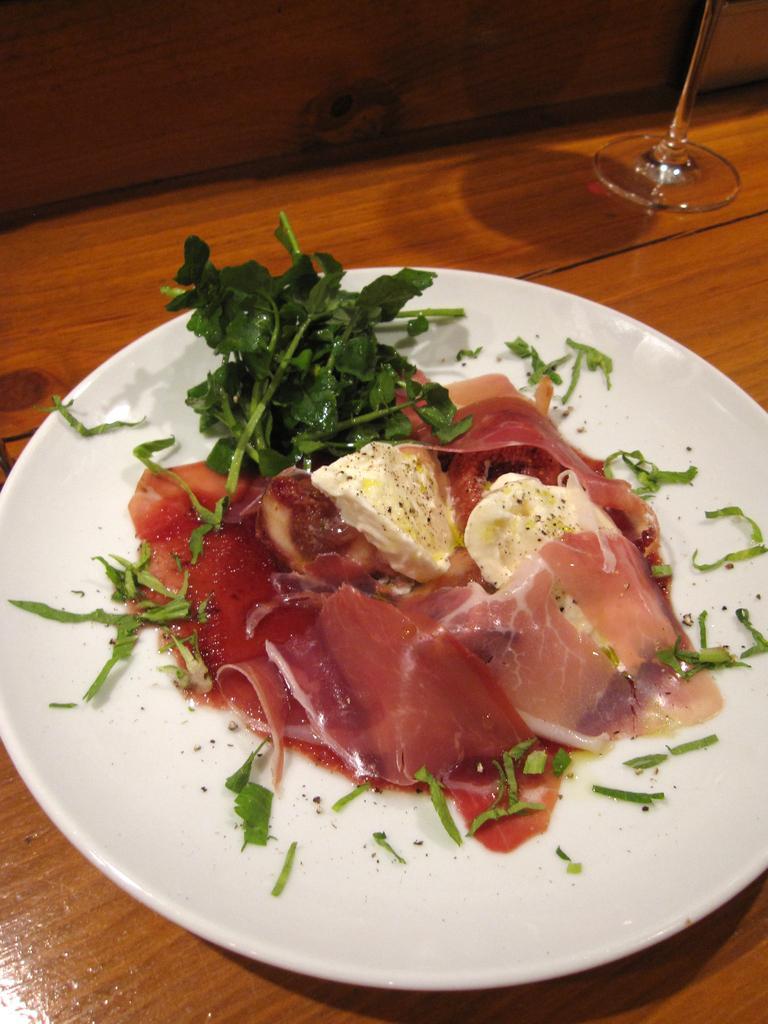How would you summarize this image in a sentence or two? In the center of the image there is a table. On the table we can see a plate of food item, glass are there. 